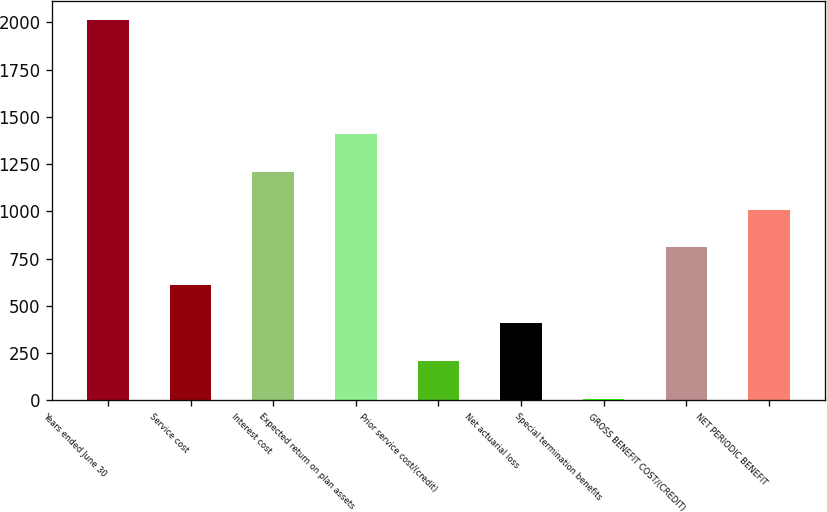Convert chart. <chart><loc_0><loc_0><loc_500><loc_500><bar_chart><fcel>Years ended June 30<fcel>Service cost<fcel>Interest cost<fcel>Expected return on plan assets<fcel>Prior service cost/(credit)<fcel>Net actuarial loss<fcel>Special termination benefits<fcel>GROSS BENEFIT COST/(CREDIT)<fcel>NET PERIODIC BENEFIT<nl><fcel>2014<fcel>607.7<fcel>1210.4<fcel>1411.3<fcel>205.9<fcel>406.8<fcel>5<fcel>808.6<fcel>1009.5<nl></chart> 